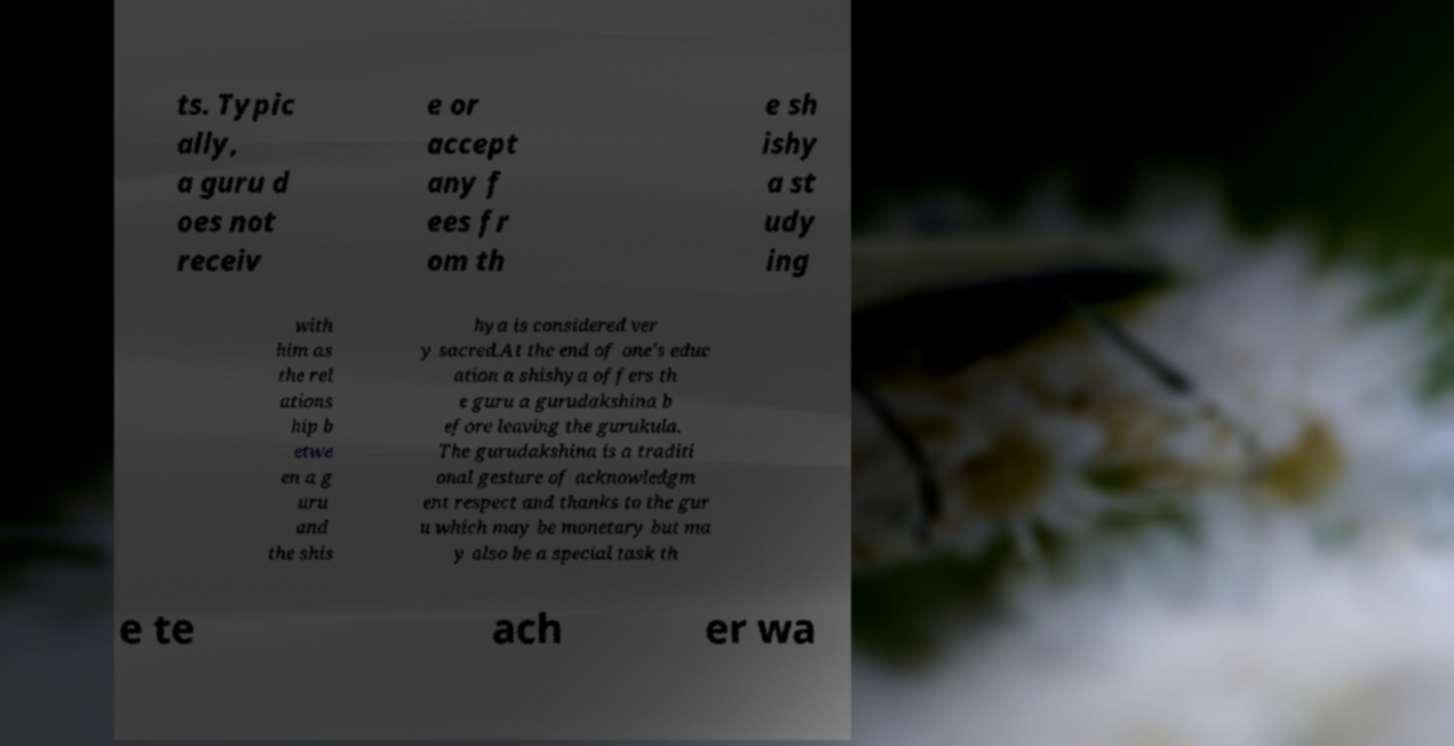Could you extract and type out the text from this image? ts. Typic ally, a guru d oes not receiv e or accept any f ees fr om th e sh ishy a st udy ing with him as the rel ations hip b etwe en a g uru and the shis hya is considered ver y sacred.At the end of one's educ ation a shishya offers th e guru a gurudakshina b efore leaving the gurukula. The gurudakshina is a traditi onal gesture of acknowledgm ent respect and thanks to the gur u which may be monetary but ma y also be a special task th e te ach er wa 